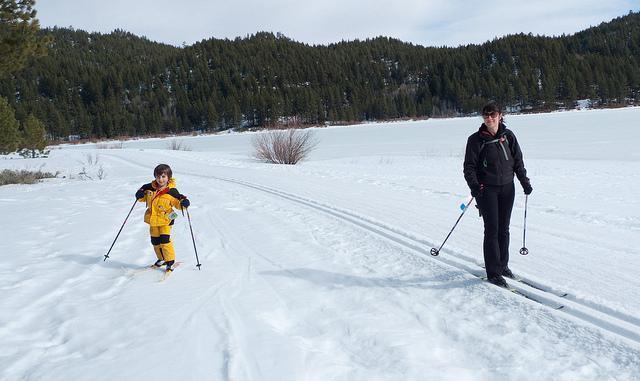How many people are there?
Give a very brief answer. 2. 